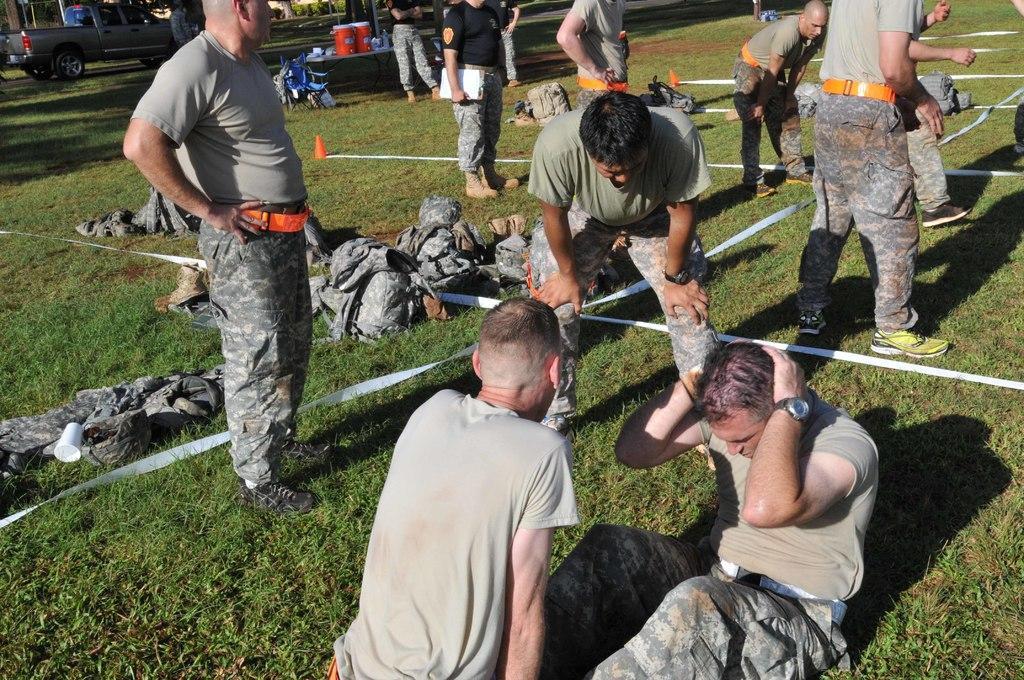In one or two sentences, can you explain what this image depicts? In this image there are a few people standing and few are sitting on the surface of the grass, in the middle of them there are ropes connected to traffic cones and there are a few clothes and objects are placed. In the background there is a vehicle and trees. 